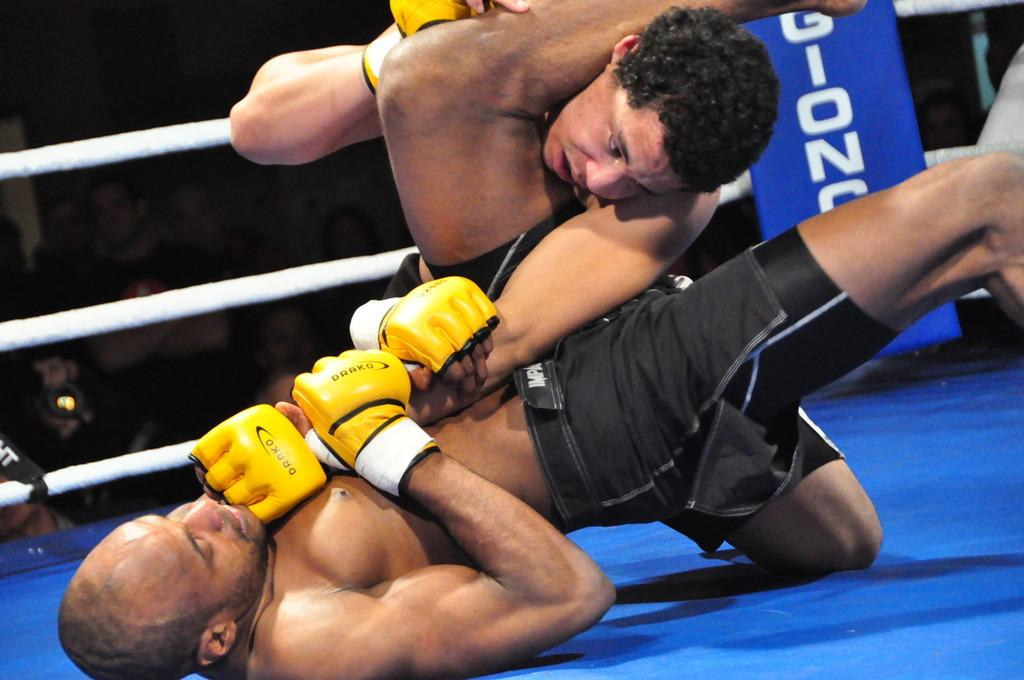<image>
Describe the image concisely. The MMA combatants are shown wearing Drako gloves. 